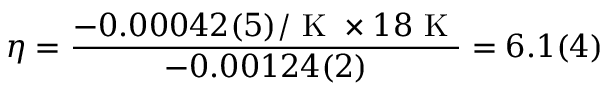<formula> <loc_0><loc_0><loc_500><loc_500>\eta = \frac { - 0 . 0 0 0 4 2 ( 5 ) / K \times 1 8 K } { - 0 . 0 0 1 2 4 ( 2 ) } = 6 . 1 ( 4 )</formula> 